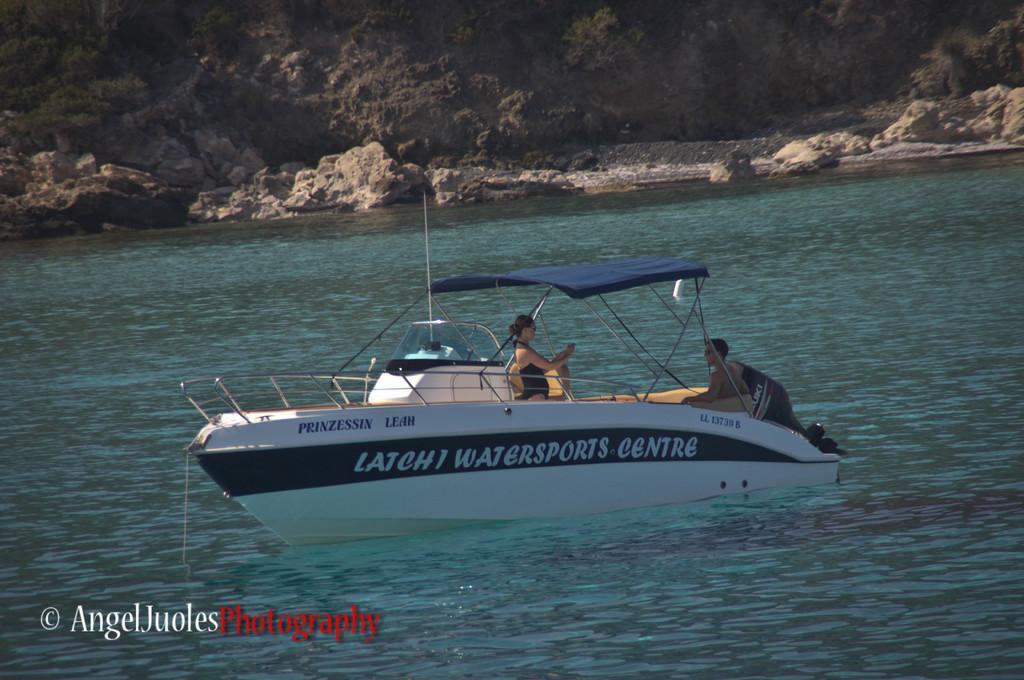Please provide a concise description of this image. In the image we can see there are two people, they are in the boat. This is a boat and the boat is in the water, this is a water and the stones, this is a watermark. 